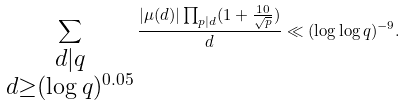Convert formula to latex. <formula><loc_0><loc_0><loc_500><loc_500>\sum _ { \substack { d | q \\ d \geq ( \log q ) ^ { 0 . 0 5 } } } \frac { | \mu ( d ) | \prod _ { p | d } ( 1 + \frac { 1 0 } { \sqrt { p } } ) } { d } \ll ( \log \log q ) ^ { - 9 } .</formula> 